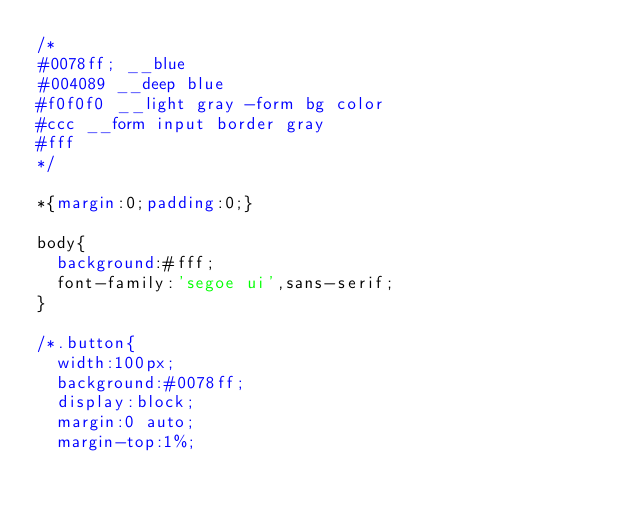Convert code to text. <code><loc_0><loc_0><loc_500><loc_500><_CSS_>/*
#0078ff; __blue
#004089 __deep blue
#f0f0f0 __light gray -form bg color
#ccc __form input border gray
#fff 
*/ 

*{margin:0;padding:0;}

body{
  background:#fff;
  font-family:'segoe ui',sans-serif;
}

/*.button{
  width:100px;
  background:#0078ff;
  display:block;
  margin:0 auto;
  margin-top:1%;</code> 